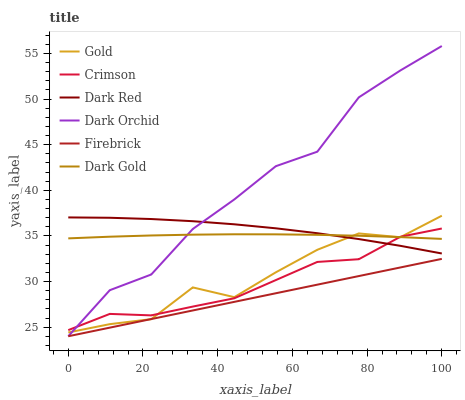Does Dark Gold have the minimum area under the curve?
Answer yes or no. No. Does Dark Gold have the maximum area under the curve?
Answer yes or no. No. Is Dark Gold the smoothest?
Answer yes or no. No. Is Dark Gold the roughest?
Answer yes or no. No. Does Dark Red have the lowest value?
Answer yes or no. No. Does Dark Gold have the highest value?
Answer yes or no. No. Is Firebrick less than Crimson?
Answer yes or no. Yes. Is Dark Gold greater than Firebrick?
Answer yes or no. Yes. Does Firebrick intersect Crimson?
Answer yes or no. No. 